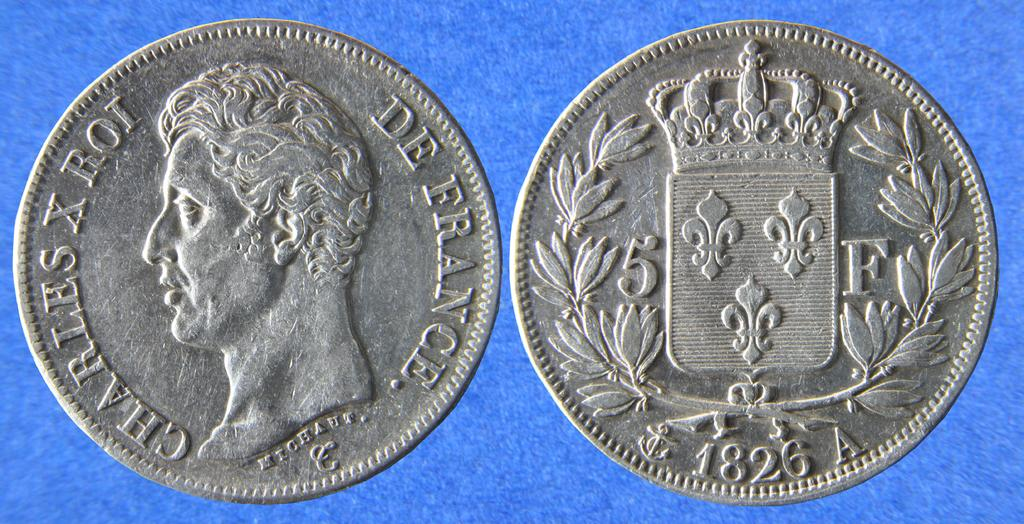Provide a one-sentence caption for the provided image. A French coin from 1826 has a face on one site and an emblem on the back. 